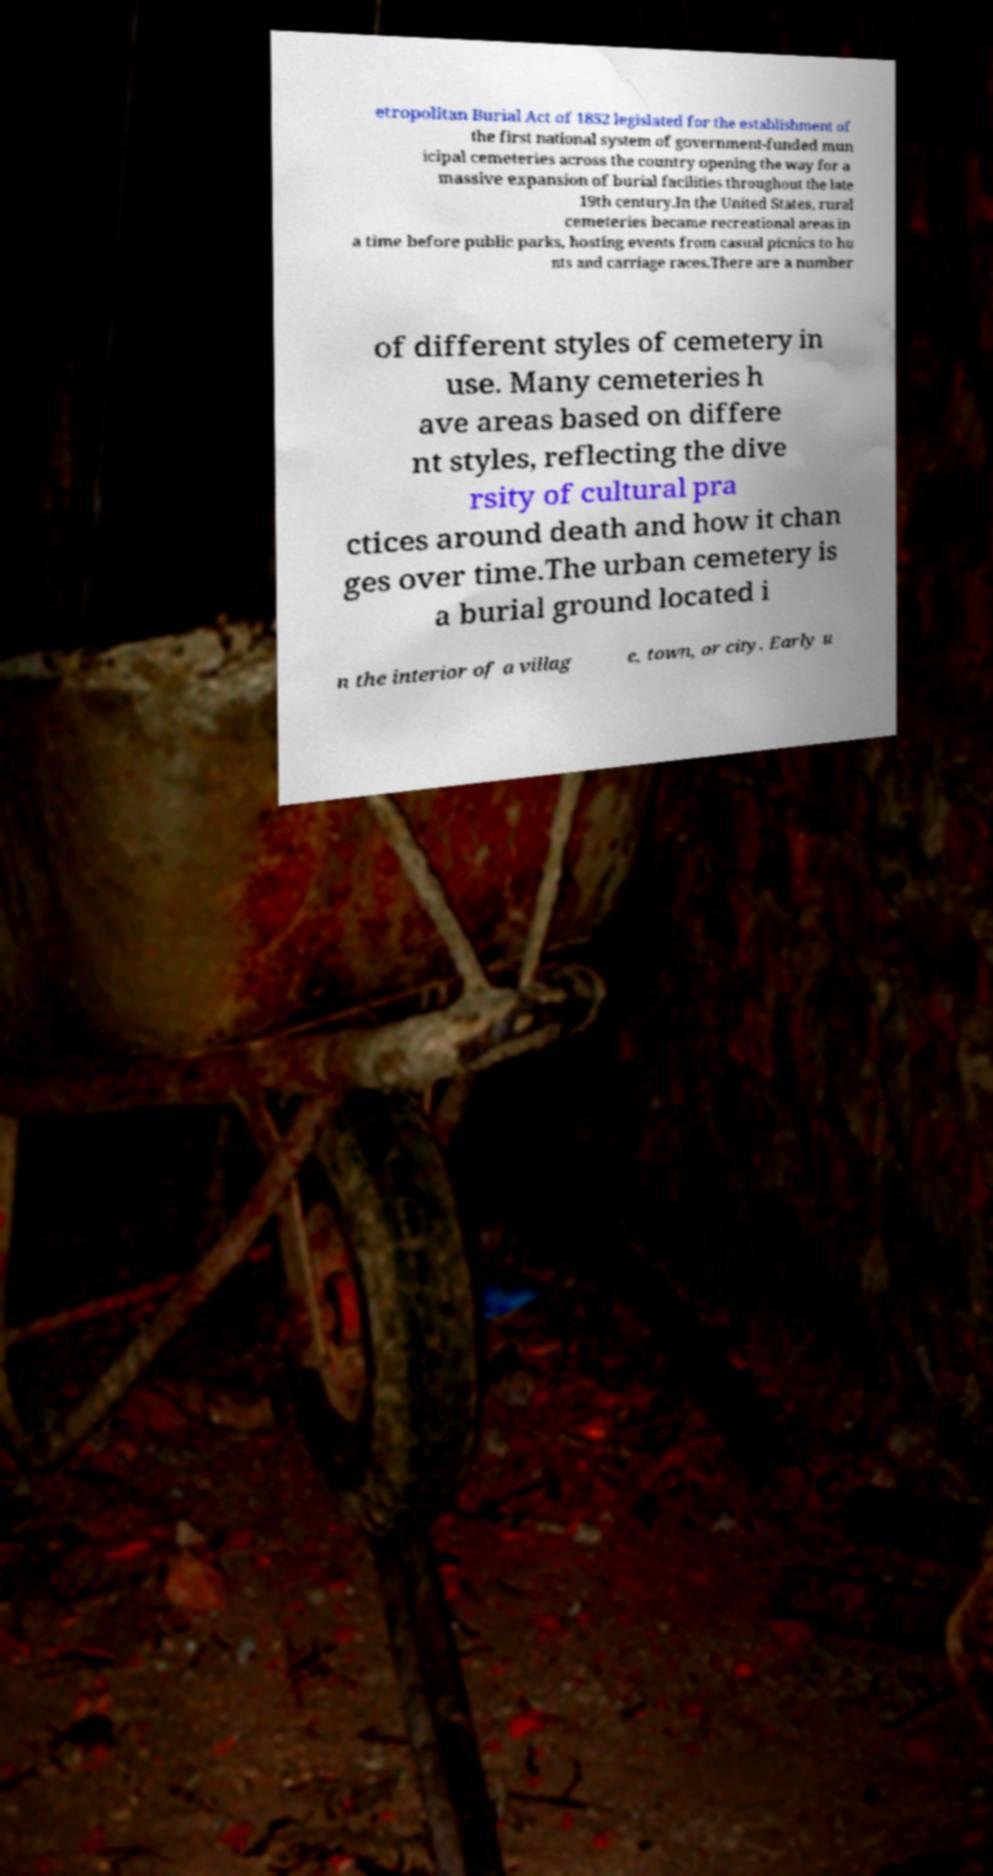Could you assist in decoding the text presented in this image and type it out clearly? etropolitan Burial Act of 1852 legislated for the establishment of the first national system of government-funded mun icipal cemeteries across the country opening the way for a massive expansion of burial facilities throughout the late 19th century.In the United States, rural cemeteries became recreational areas in a time before public parks, hosting events from casual picnics to hu nts and carriage races.There are a number of different styles of cemetery in use. Many cemeteries h ave areas based on differe nt styles, reflecting the dive rsity of cultural pra ctices around death and how it chan ges over time.The urban cemetery is a burial ground located i n the interior of a villag e, town, or city. Early u 